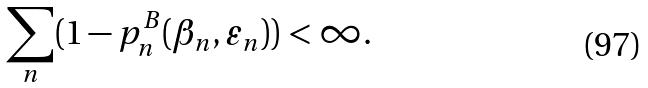<formula> <loc_0><loc_0><loc_500><loc_500>\sum _ { n } ( 1 - p ^ { B } _ { n } ( \beta _ { n } , \varepsilon _ { n } ) ) < \infty .</formula> 